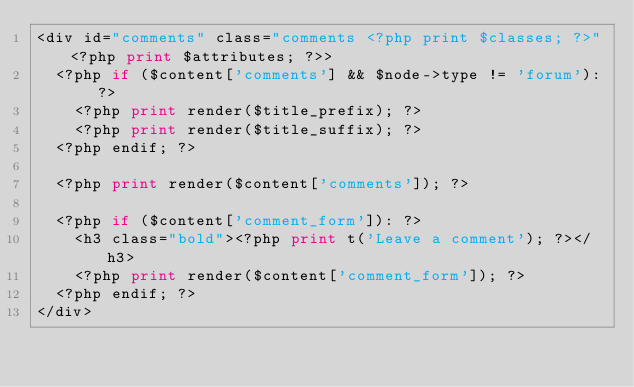<code> <loc_0><loc_0><loc_500><loc_500><_PHP_><div id="comments" class="comments <?php print $classes; ?>"<?php print $attributes; ?>>
  <?php if ($content['comments'] && $node->type != 'forum'): ?>
    <?php print render($title_prefix); ?>
    <?php print render($title_suffix); ?>
  <?php endif; ?>

  <?php print render($content['comments']); ?>

  <?php if ($content['comment_form']): ?>
    <h3 class="bold"><?php print t('Leave a comment'); ?></h3>
    <?php print render($content['comment_form']); ?>
  <?php endif; ?>
</div></code> 